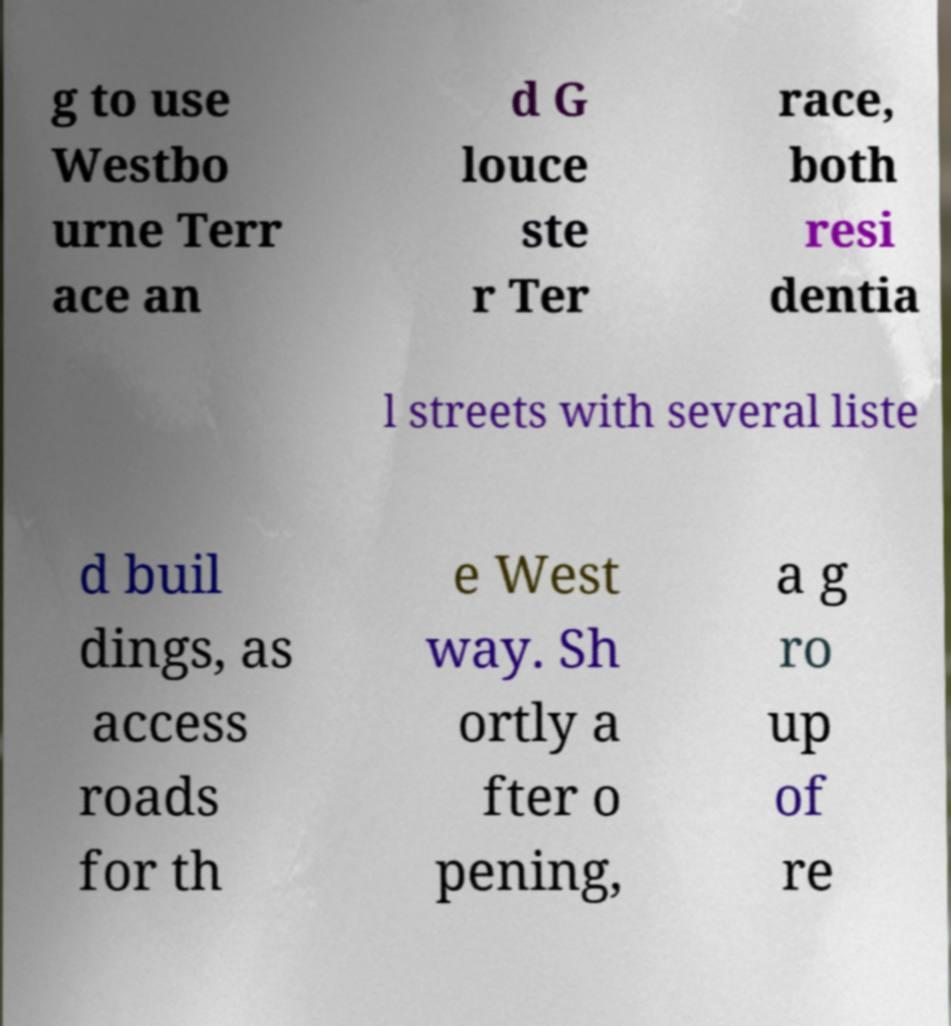Please read and relay the text visible in this image. What does it say? g to use Westbo urne Terr ace an d G louce ste r Ter race, both resi dentia l streets with several liste d buil dings, as access roads for th e West way. Sh ortly a fter o pening, a g ro up of re 